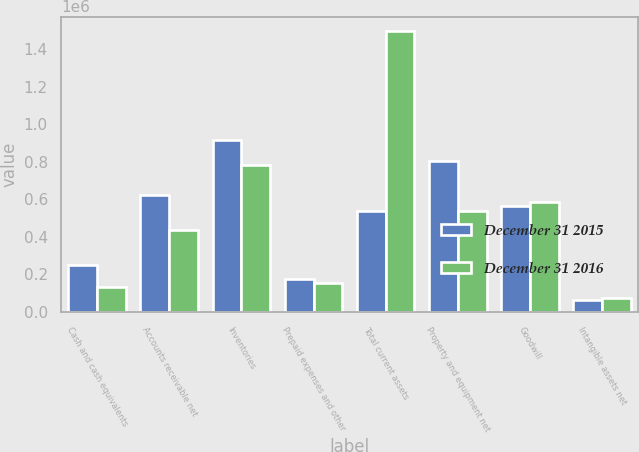<chart> <loc_0><loc_0><loc_500><loc_500><stacked_bar_chart><ecel><fcel>Cash and cash equivalents<fcel>Accounts receivable net<fcel>Inventories<fcel>Prepaid expenses and other<fcel>Total current assets<fcel>Property and equipment net<fcel>Goodwill<fcel>Intangible assets net<nl><fcel>December 31 2015<fcel>250470<fcel>622685<fcel>917491<fcel>174507<fcel>538531<fcel>804211<fcel>563591<fcel>64310<nl><fcel>December 31 2016<fcel>129852<fcel>433638<fcel>783031<fcel>152242<fcel>1.49876e+06<fcel>538531<fcel>585181<fcel>75686<nl></chart> 